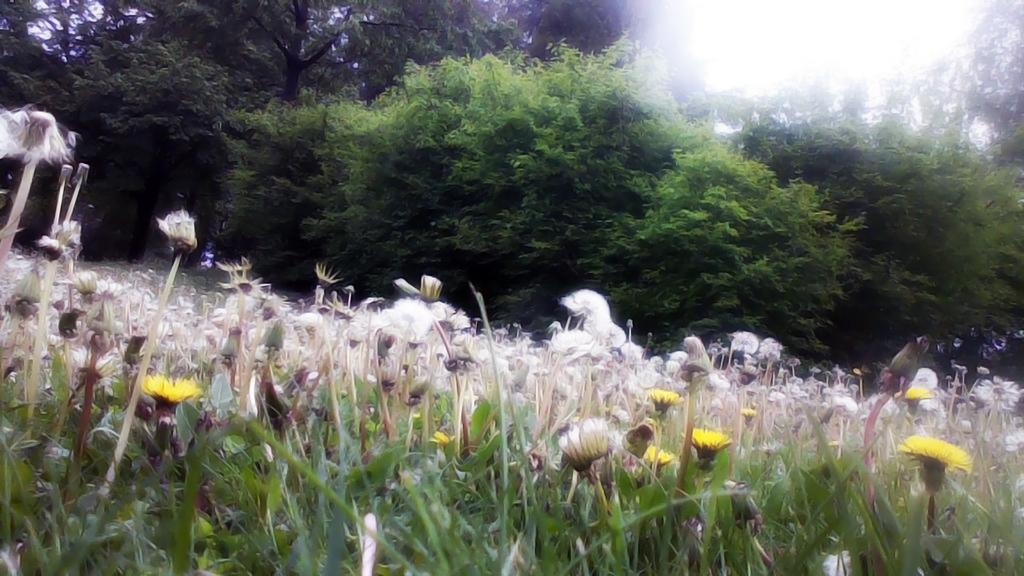What types of flowers are in the middle of the picture? There are white and yellow color flowers in the middle of the picture. What can be seen in the background of the picture? There are trees in the background of the picture. Where can you find popcorn being sold in the picture? There is no mention of popcorn or any place selling it in the picture. 